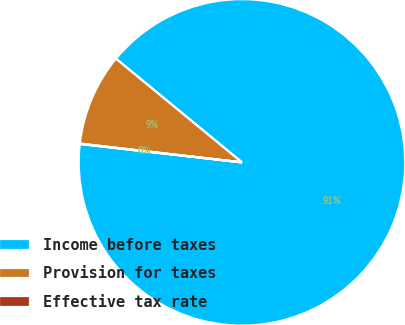<chart> <loc_0><loc_0><loc_500><loc_500><pie_chart><fcel>Income before taxes<fcel>Provision for taxes<fcel>Effective tax rate<nl><fcel>90.84%<fcel>9.12%<fcel>0.04%<nl></chart> 